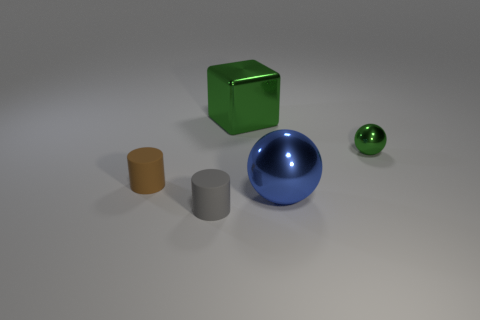Are there fewer gray rubber objects that are behind the large green metallic thing than green objects that are in front of the gray matte object?
Offer a terse response. No. There is a large thing that is behind the small brown matte thing; does it have the same shape as the gray matte object?
Your response must be concise. No. Is there anything else that has the same material as the tiny ball?
Your answer should be compact. Yes. Is the material of the small cylinder to the left of the gray matte cylinder the same as the big ball?
Provide a short and direct response. No. There is a cylinder to the right of the tiny cylinder behind the rubber thing that is right of the brown rubber cylinder; what is its material?
Your response must be concise. Rubber. How many other objects are there of the same shape as the blue metal thing?
Your response must be concise. 1. There is a metal object that is behind the green ball; what color is it?
Make the answer very short. Green. There is a cylinder that is in front of the small matte cylinder behind the gray cylinder; how many green balls are to the right of it?
Provide a succinct answer. 1. What number of big balls are behind the green object on the right side of the big blue thing?
Provide a succinct answer. 0. How many brown matte things are in front of the shiny block?
Offer a terse response. 1. 